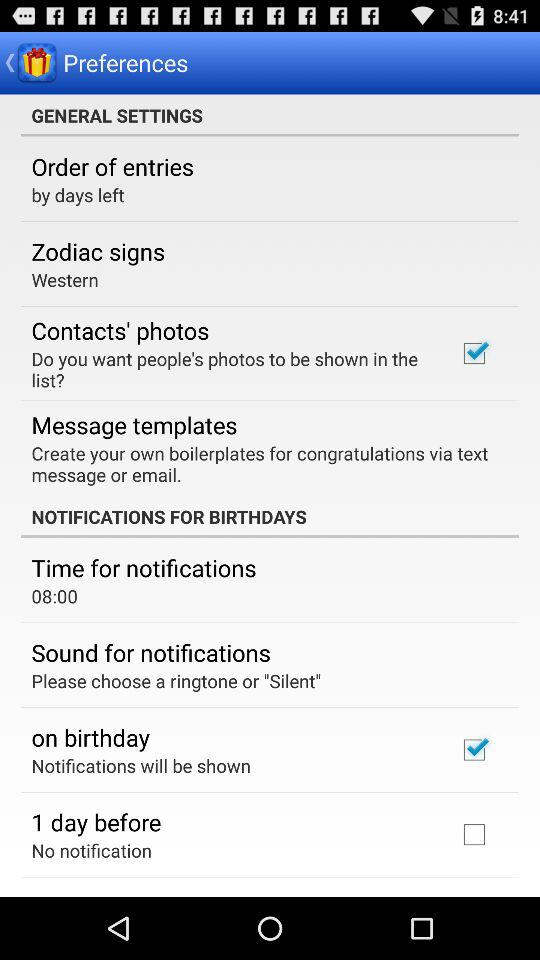What is the current status of "on birthday"? The current status of "on birthday" is "on". 